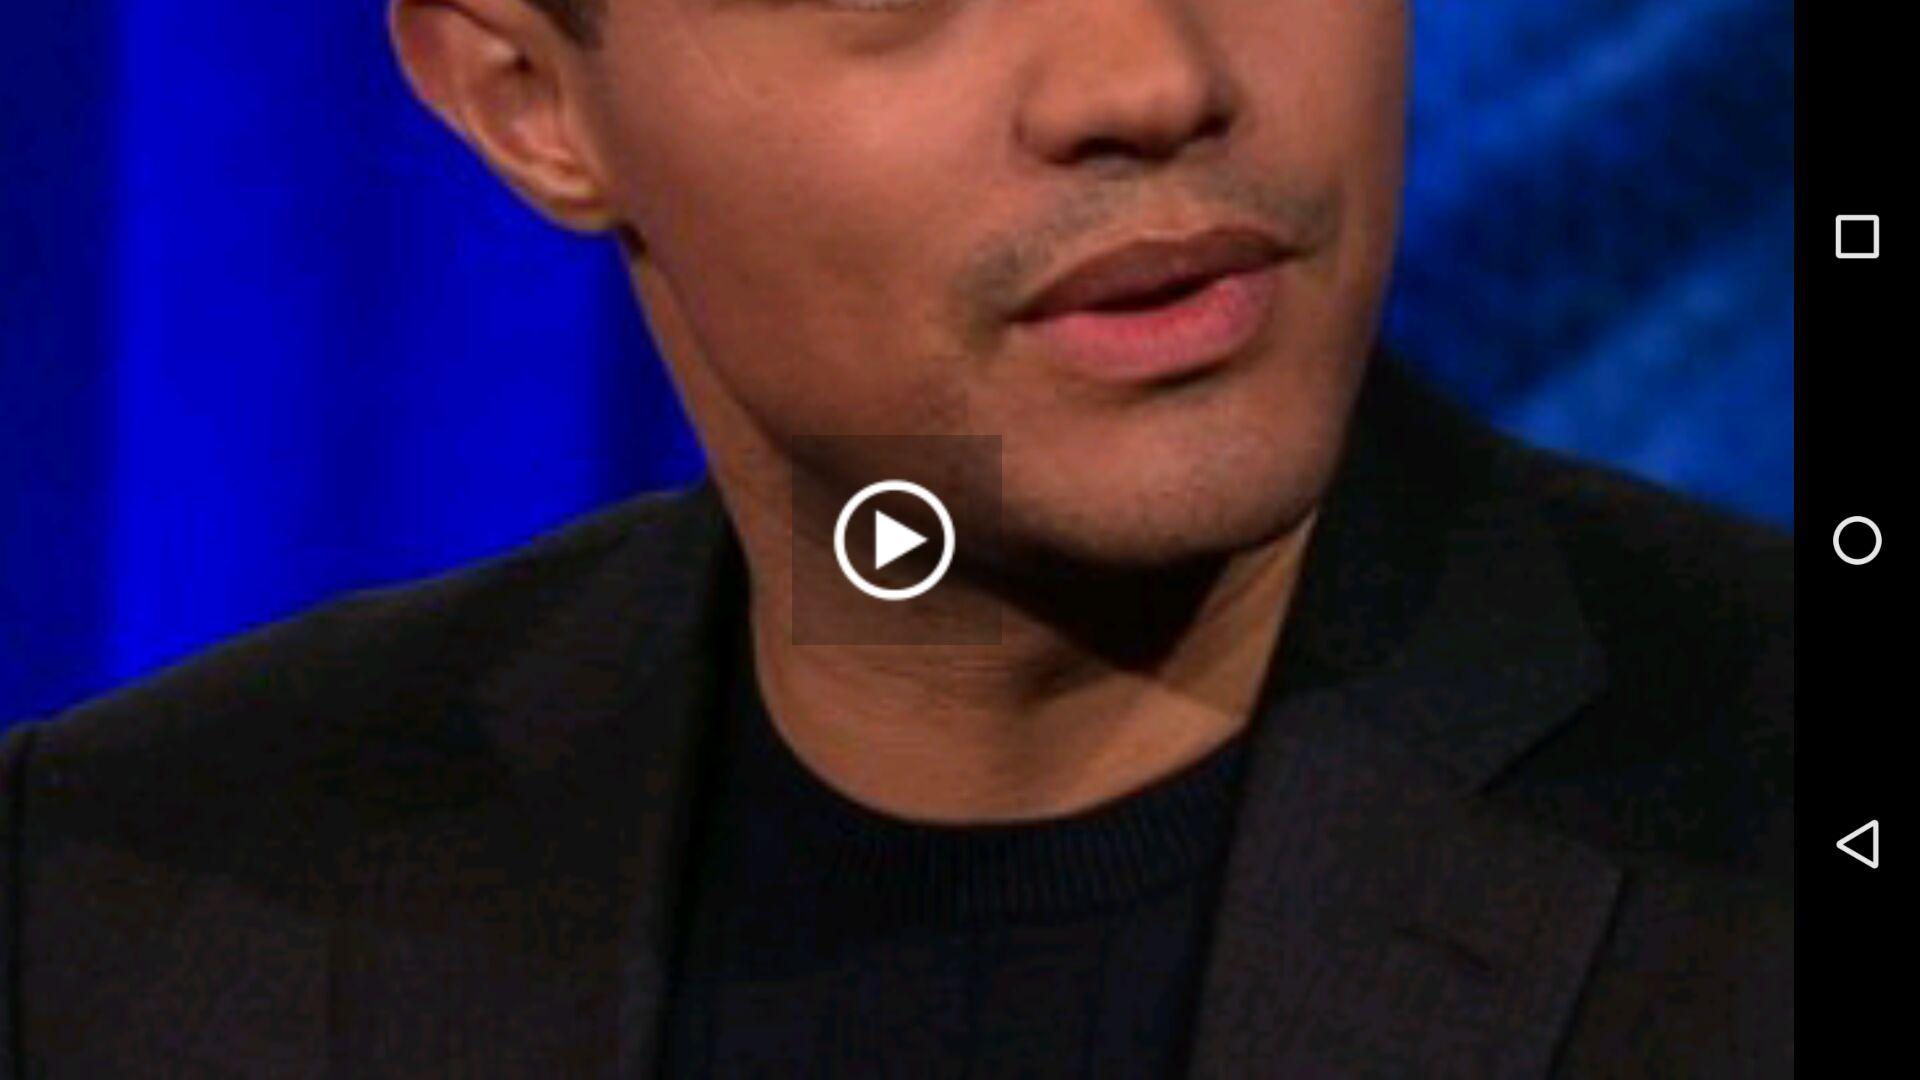What is the total time duration of the "Sanders: House plan is Robin Hood in reverse" video? The total time duration of the "Sanders: House plan is Robin Hood in reverse" video is 1 minutes 6 seconds. 